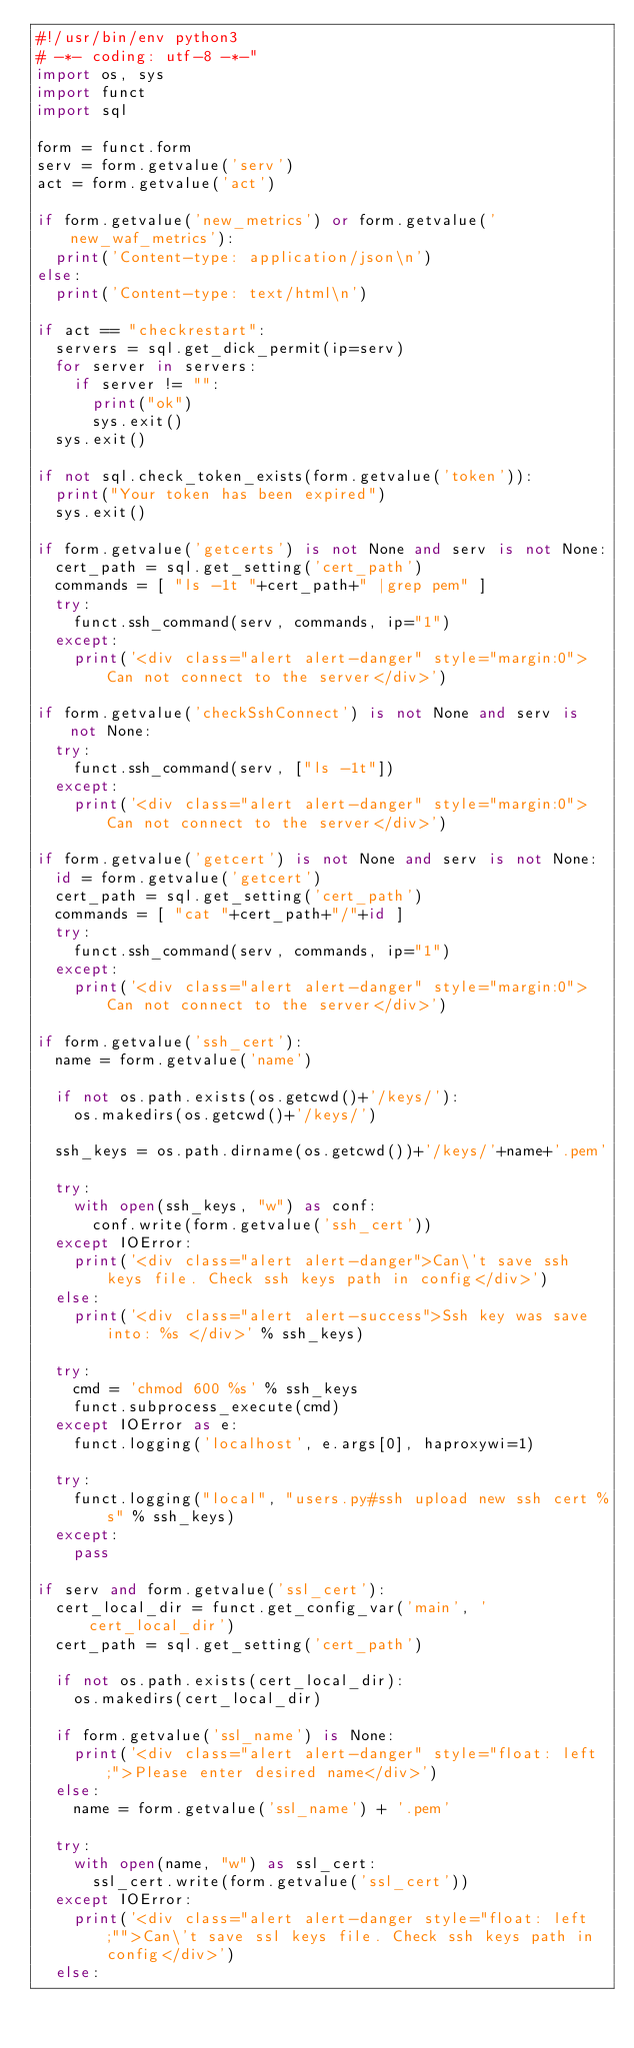<code> <loc_0><loc_0><loc_500><loc_500><_Python_>#!/usr/bin/env python3
# -*- coding: utf-8 -*-"
import os, sys
import funct
import sql

form = funct.form
serv = form.getvalue('serv')
act = form.getvalue('act')

if form.getvalue('new_metrics') or form.getvalue('new_waf_metrics'):
	print('Content-type: application/json\n')
else:
	print('Content-type: text/html\n')

if act == "checkrestart":
	servers = sql.get_dick_permit(ip=serv)
	for server in servers:
		if server != "":
			print("ok")
			sys.exit()
	sys.exit()

if not sql.check_token_exists(form.getvalue('token')):
	print("Your token has been expired")
	sys.exit()
		
if form.getvalue('getcerts') is not None and serv is not None:
	cert_path = sql.get_setting('cert_path')
	commands = [ "ls -1t "+cert_path+" |grep pem" ]
	try:
		funct.ssh_command(serv, commands, ip="1")
	except:
		print('<div class="alert alert-danger" style="margin:0">Can not connect to the server</div>')

if form.getvalue('checkSshConnect') is not None and serv is not None:
	try:
		funct.ssh_command(serv, ["ls -1t"])
	except:
		print('<div class="alert alert-danger" style="margin:0">Can not connect to the server</div>')
		
if form.getvalue('getcert') is not None and serv is not None:
	id = form.getvalue('getcert')
	cert_path = sql.get_setting('cert_path')
	commands = [ "cat "+cert_path+"/"+id ]
	try:
		funct.ssh_command(serv, commands, ip="1")
	except:
		print('<div class="alert alert-danger" style="margin:0">Can not connect to the server</div>')
		
if form.getvalue('ssh_cert'):
	name = form.getvalue('name')
	
	if not os.path.exists(os.getcwd()+'/keys/'):
		os.makedirs(os.getcwd()+'/keys/')
	
	ssh_keys = os.path.dirname(os.getcwd())+'/keys/'+name+'.pem'
	
	try:
		with open(ssh_keys, "w") as conf:
			conf.write(form.getvalue('ssh_cert'))
	except IOError:
		print('<div class="alert alert-danger">Can\'t save ssh keys file. Check ssh keys path in config</div>')
	else:
		print('<div class="alert alert-success">Ssh key was save into: %s </div>' % ssh_keys)
		
	try:
		cmd = 'chmod 600 %s' % ssh_keys
		funct.subprocess_execute(cmd)
	except IOError as e:
		funct.logging('localhost', e.args[0], haproxywi=1)
		
	try:
		funct.logging("local", "users.py#ssh upload new ssh cert %s" % ssh_keys)
	except:
		pass
			
if serv and form.getvalue('ssl_cert'):
	cert_local_dir = funct.get_config_var('main', 'cert_local_dir')
	cert_path = sql.get_setting('cert_path')
	
	if not os.path.exists(cert_local_dir):
		os.makedirs(cert_local_dir)
	
	if form.getvalue('ssl_name') is None:
		print('<div class="alert alert-danger" style="float: left;">Please enter desired name</div>')
	else:
		name = form.getvalue('ssl_name') + '.pem'
	
	try:
		with open(name, "w") as ssl_cert:
			ssl_cert.write(form.getvalue('ssl_cert'))
	except IOError:
		print('<div class="alert alert-danger style="float: left;"">Can\'t save ssl keys file. Check ssh keys path in config</div>')
	else:</code> 